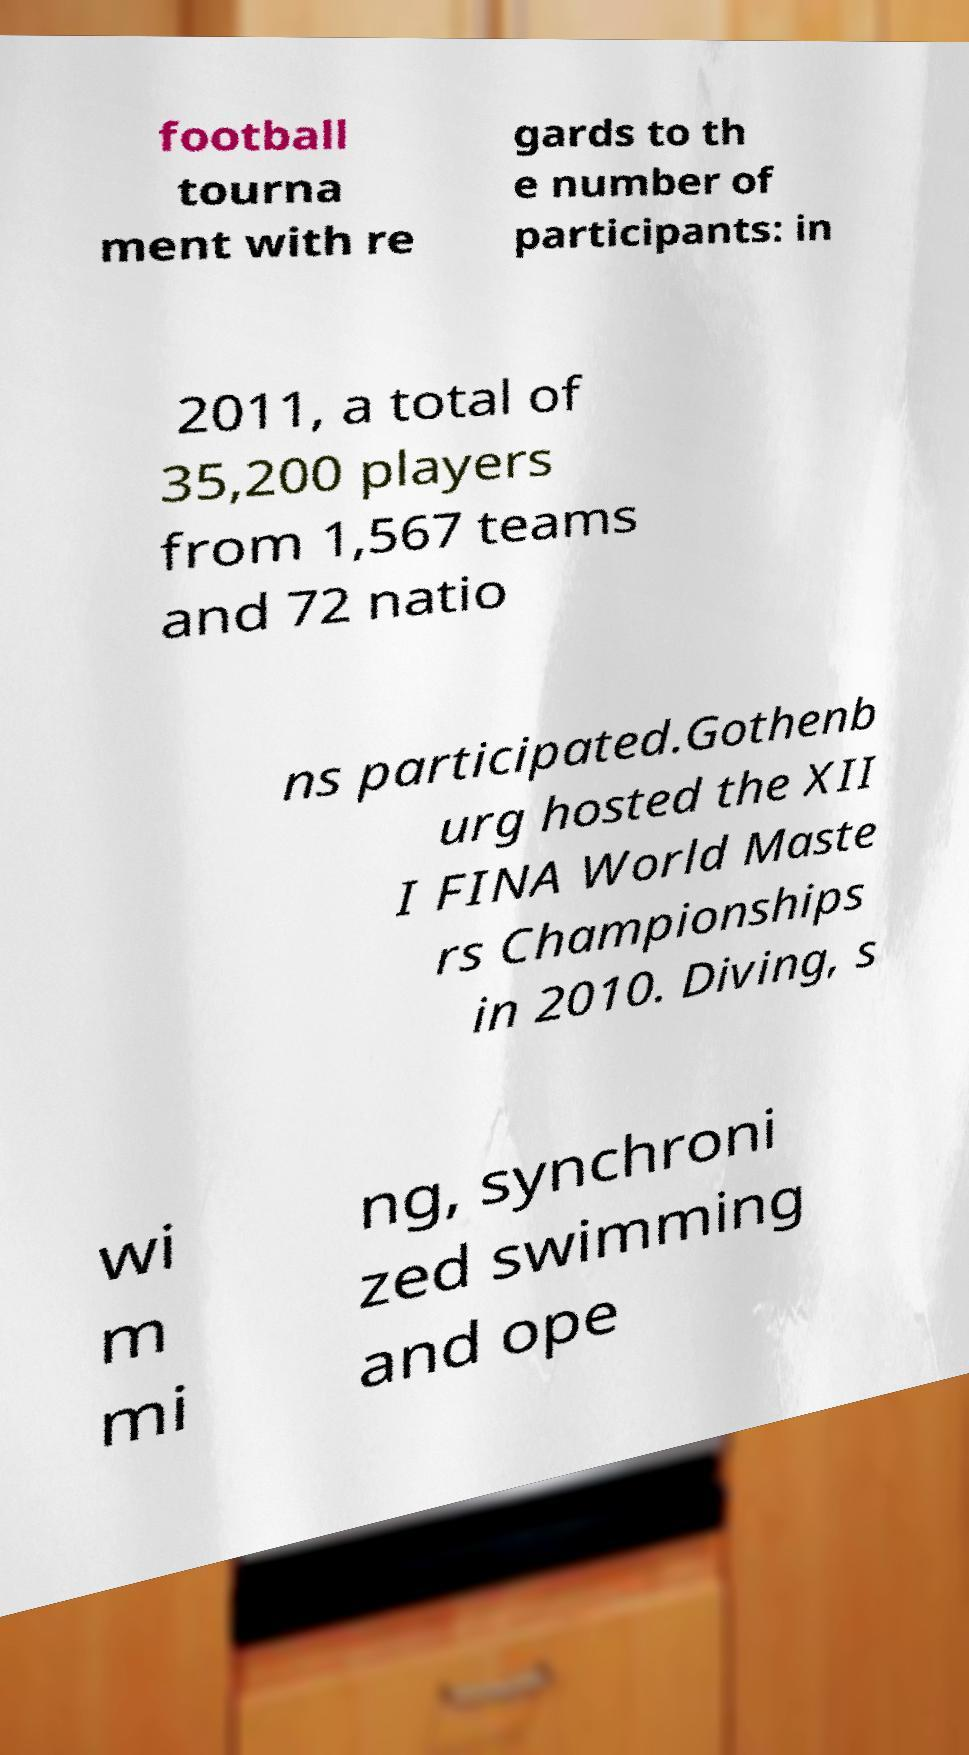Can you read and provide the text displayed in the image?This photo seems to have some interesting text. Can you extract and type it out for me? football tourna ment with re gards to th e number of participants: in 2011, a total of 35,200 players from 1,567 teams and 72 natio ns participated.Gothenb urg hosted the XII I FINA World Maste rs Championships in 2010. Diving, s wi m mi ng, synchroni zed swimming and ope 